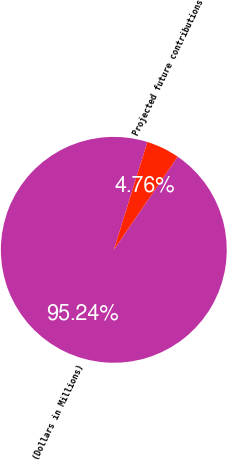Convert chart. <chart><loc_0><loc_0><loc_500><loc_500><pie_chart><fcel>(Dollars in Millions)<fcel>Projected future contributions<nl><fcel>95.24%<fcel>4.76%<nl></chart> 